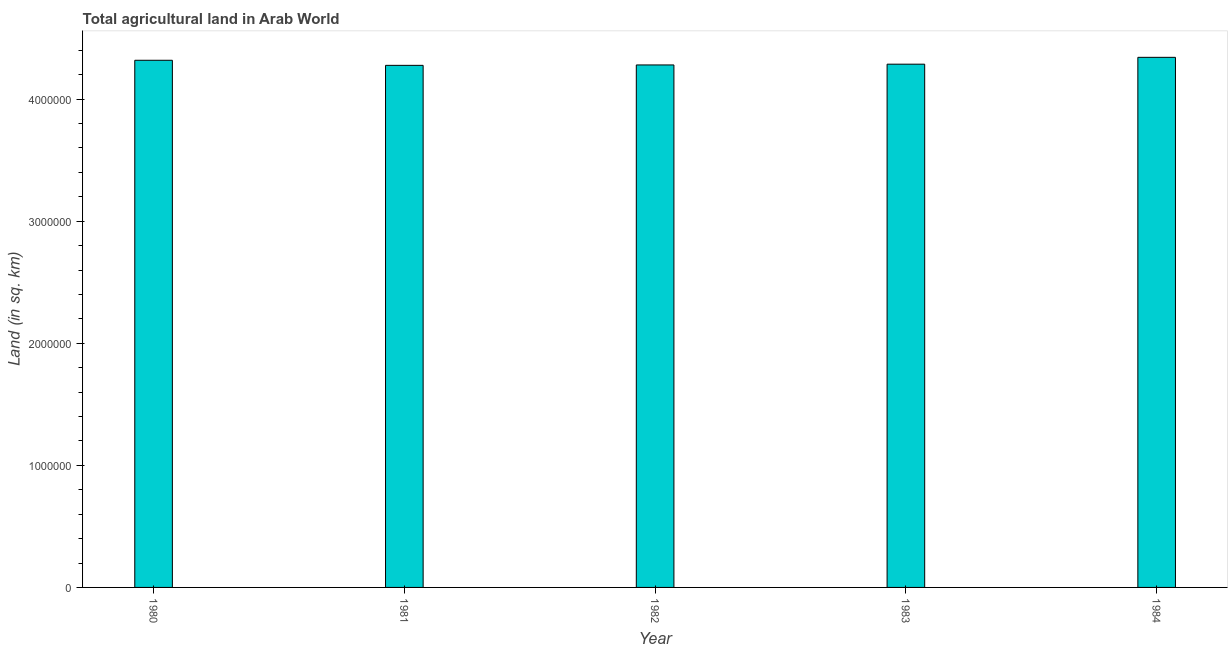Does the graph contain grids?
Offer a terse response. No. What is the title of the graph?
Your answer should be very brief. Total agricultural land in Arab World. What is the label or title of the Y-axis?
Provide a succinct answer. Land (in sq. km). What is the agricultural land in 1981?
Offer a terse response. 4.28e+06. Across all years, what is the maximum agricultural land?
Keep it short and to the point. 4.34e+06. Across all years, what is the minimum agricultural land?
Provide a short and direct response. 4.28e+06. In which year was the agricultural land maximum?
Your answer should be compact. 1984. In which year was the agricultural land minimum?
Offer a very short reply. 1981. What is the sum of the agricultural land?
Provide a short and direct response. 2.15e+07. What is the difference between the agricultural land in 1981 and 1982?
Provide a succinct answer. -3297.4. What is the average agricultural land per year?
Give a very brief answer. 4.30e+06. What is the median agricultural land?
Your response must be concise. 4.29e+06. In how many years, is the agricultural land greater than 3600000 sq. km?
Your response must be concise. 5. What is the ratio of the agricultural land in 1980 to that in 1982?
Your answer should be very brief. 1.01. What is the difference between the highest and the second highest agricultural land?
Provide a succinct answer. 2.41e+04. What is the difference between the highest and the lowest agricultural land?
Make the answer very short. 6.57e+04. In how many years, is the agricultural land greater than the average agricultural land taken over all years?
Provide a succinct answer. 2. How many years are there in the graph?
Give a very brief answer. 5. What is the difference between two consecutive major ticks on the Y-axis?
Your answer should be very brief. 1.00e+06. Are the values on the major ticks of Y-axis written in scientific E-notation?
Your answer should be very brief. No. What is the Land (in sq. km) in 1980?
Make the answer very short. 4.32e+06. What is the Land (in sq. km) in 1981?
Give a very brief answer. 4.28e+06. What is the Land (in sq. km) in 1982?
Your answer should be compact. 4.28e+06. What is the Land (in sq. km) of 1983?
Offer a very short reply. 4.29e+06. What is the Land (in sq. km) of 1984?
Give a very brief answer. 4.34e+06. What is the difference between the Land (in sq. km) in 1980 and 1981?
Give a very brief answer. 4.16e+04. What is the difference between the Land (in sq. km) in 1980 and 1982?
Ensure brevity in your answer.  3.83e+04. What is the difference between the Land (in sq. km) in 1980 and 1983?
Offer a very short reply. 3.20e+04. What is the difference between the Land (in sq. km) in 1980 and 1984?
Provide a short and direct response. -2.41e+04. What is the difference between the Land (in sq. km) in 1981 and 1982?
Give a very brief answer. -3297.4. What is the difference between the Land (in sq. km) in 1981 and 1983?
Ensure brevity in your answer.  -9671.4. What is the difference between the Land (in sq. km) in 1981 and 1984?
Offer a very short reply. -6.57e+04. What is the difference between the Land (in sq. km) in 1982 and 1983?
Keep it short and to the point. -6374. What is the difference between the Land (in sq. km) in 1982 and 1984?
Offer a very short reply. -6.24e+04. What is the difference between the Land (in sq. km) in 1983 and 1984?
Your response must be concise. -5.61e+04. What is the ratio of the Land (in sq. km) in 1981 to that in 1982?
Make the answer very short. 1. What is the ratio of the Land (in sq. km) in 1981 to that in 1983?
Your answer should be compact. 1. What is the ratio of the Land (in sq. km) in 1981 to that in 1984?
Offer a very short reply. 0.98. What is the ratio of the Land (in sq. km) in 1982 to that in 1984?
Make the answer very short. 0.99. 